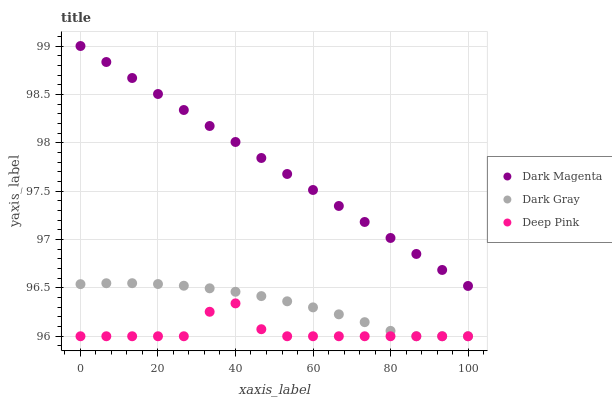Does Deep Pink have the minimum area under the curve?
Answer yes or no. Yes. Does Dark Magenta have the maximum area under the curve?
Answer yes or no. Yes. Does Dark Magenta have the minimum area under the curve?
Answer yes or no. No. Does Deep Pink have the maximum area under the curve?
Answer yes or no. No. Is Dark Magenta the smoothest?
Answer yes or no. Yes. Is Deep Pink the roughest?
Answer yes or no. Yes. Is Deep Pink the smoothest?
Answer yes or no. No. Is Dark Magenta the roughest?
Answer yes or no. No. Does Dark Gray have the lowest value?
Answer yes or no. Yes. Does Dark Magenta have the lowest value?
Answer yes or no. No. Does Dark Magenta have the highest value?
Answer yes or no. Yes. Does Deep Pink have the highest value?
Answer yes or no. No. Is Dark Gray less than Dark Magenta?
Answer yes or no. Yes. Is Dark Magenta greater than Deep Pink?
Answer yes or no. Yes. Does Deep Pink intersect Dark Gray?
Answer yes or no. Yes. Is Deep Pink less than Dark Gray?
Answer yes or no. No. Is Deep Pink greater than Dark Gray?
Answer yes or no. No. Does Dark Gray intersect Dark Magenta?
Answer yes or no. No. 